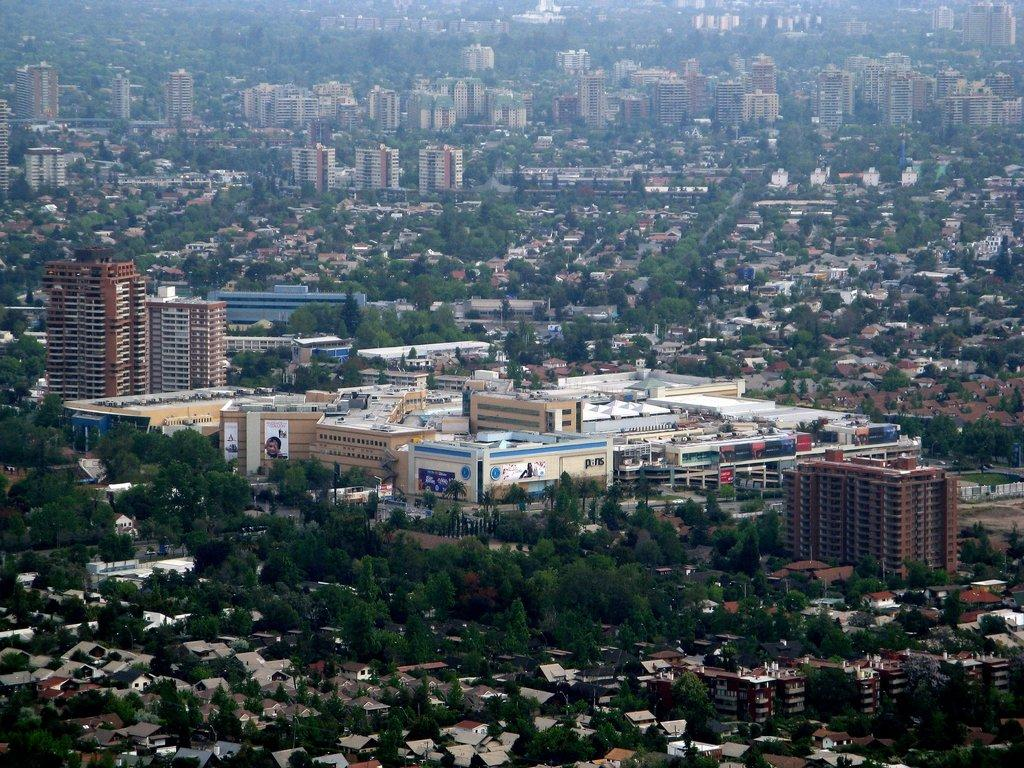What type of natural elements can be seen in the image? There are trees in the image. What type of man-made structures are present in the image? There are buildings in the image. What type of produce is being harvested from the sidewalk in the image? There is no sidewalk or produce present in the image. What type of farming equipment can be seen near the trees in the image? There is no farming equipment, such as a plough, present in the image. 